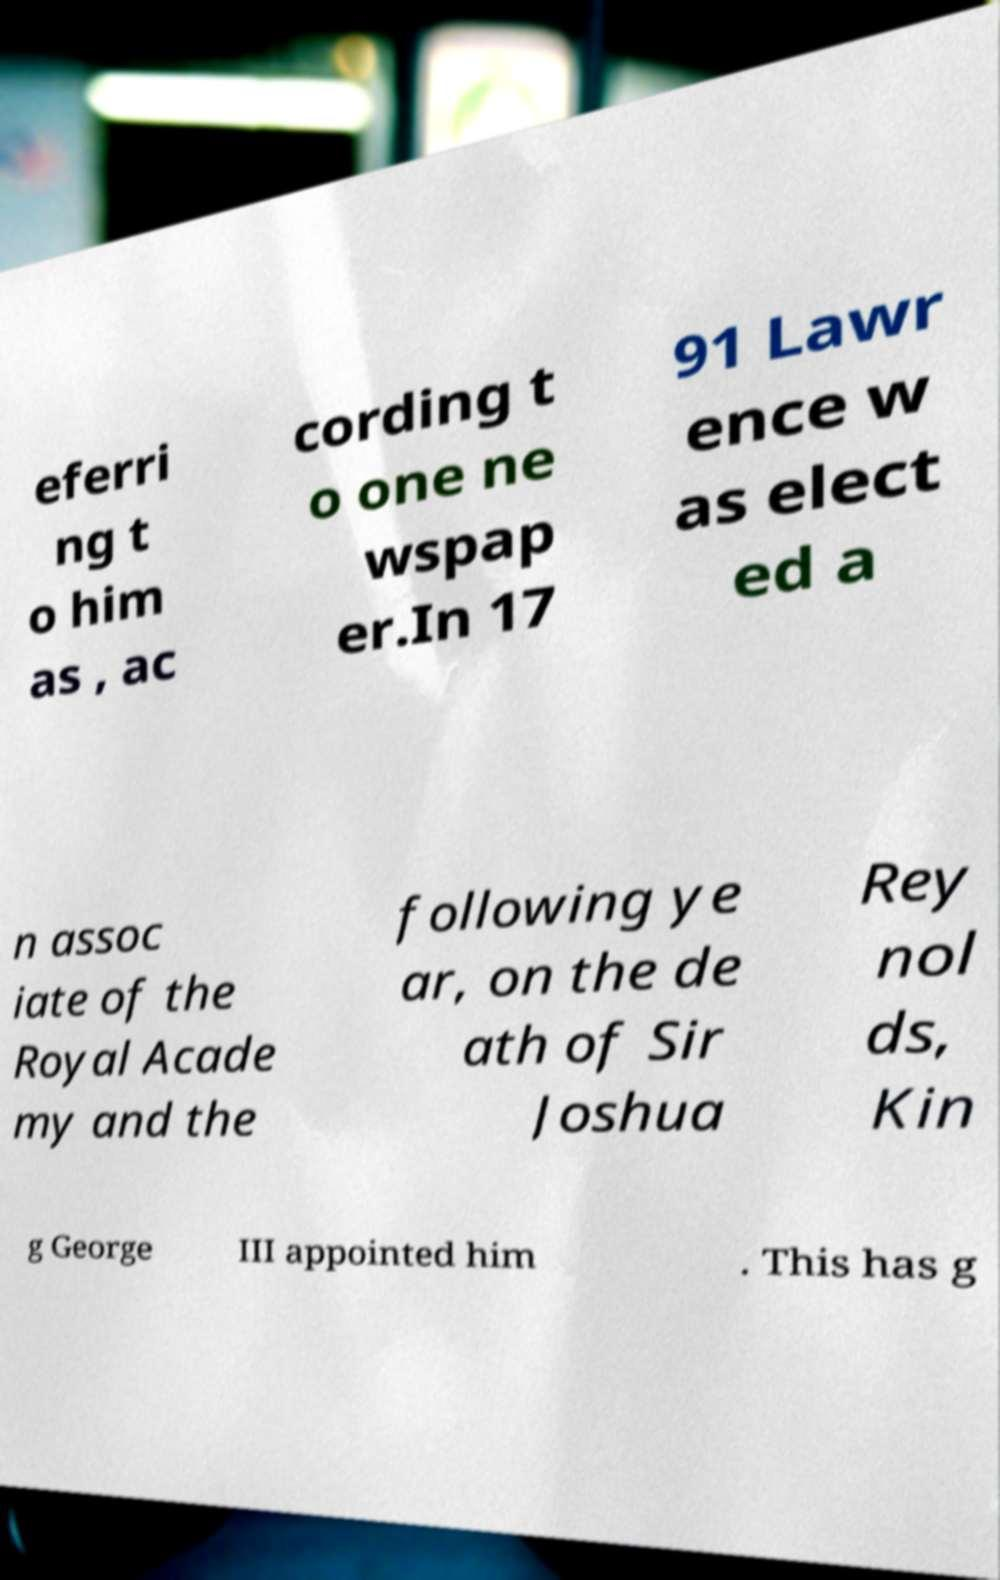Please read and relay the text visible in this image. What does it say? eferri ng t o him as , ac cording t o one ne wspap er.In 17 91 Lawr ence w as elect ed a n assoc iate of the Royal Acade my and the following ye ar, on the de ath of Sir Joshua Rey nol ds, Kin g George III appointed him . This has g 